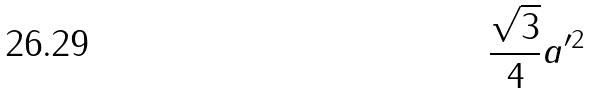Convert formula to latex. <formula><loc_0><loc_0><loc_500><loc_500>\frac { \sqrt { 3 } } { 4 } a ^ { \prime 2 }</formula> 